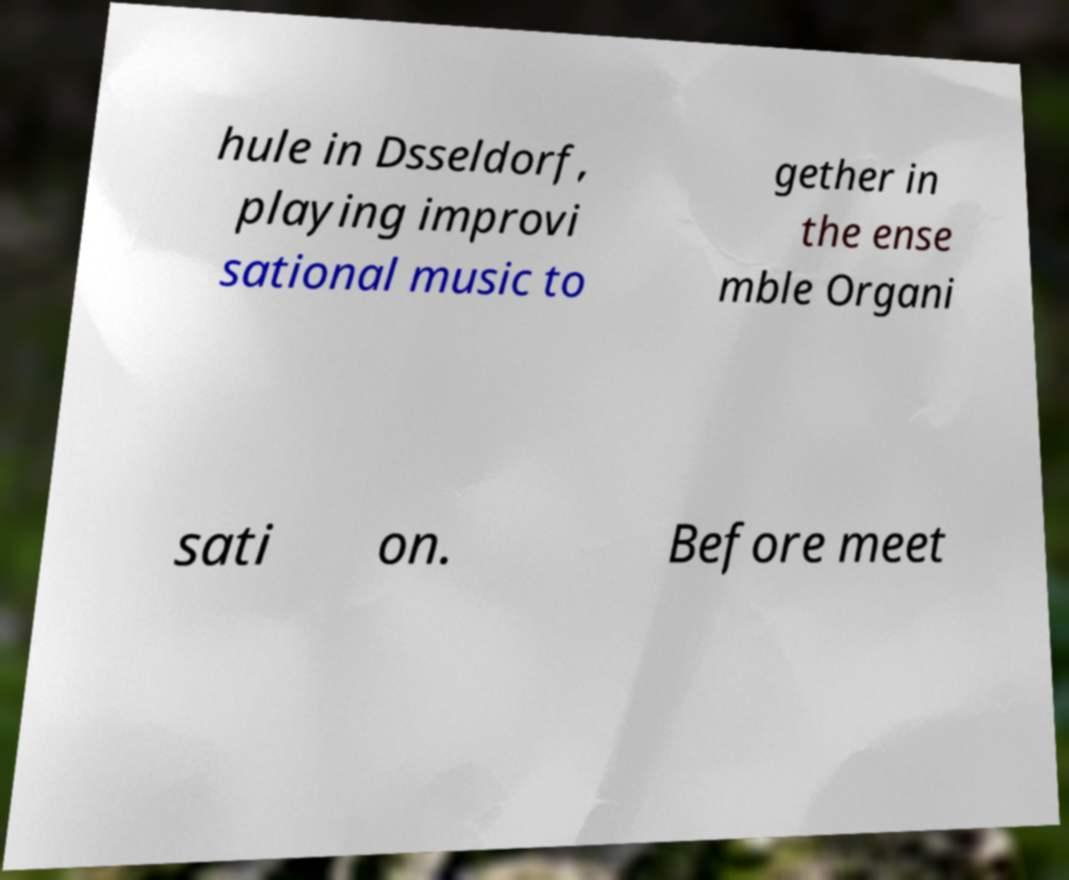Please read and relay the text visible in this image. What does it say? hule in Dsseldorf, playing improvi sational music to gether in the ense mble Organi sati on. Before meet 